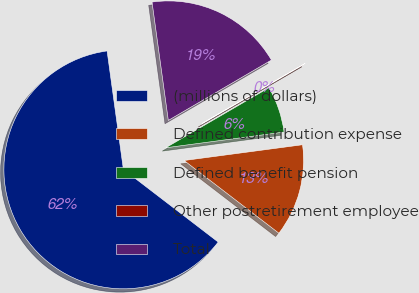Convert chart to OTSL. <chart><loc_0><loc_0><loc_500><loc_500><pie_chart><fcel>(millions of dollars)<fcel>Defined contribution expense<fcel>Defined benefit pension<fcel>Other postretirement employee<fcel>Total<nl><fcel>62.41%<fcel>12.52%<fcel>6.28%<fcel>0.04%<fcel>18.75%<nl></chart> 